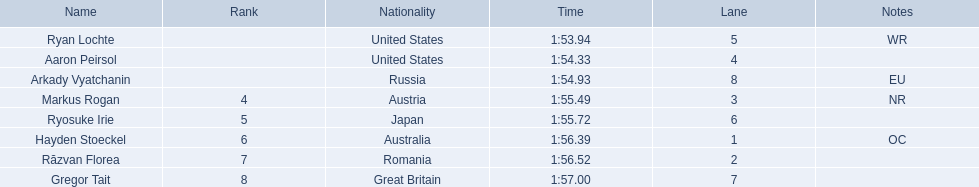Who are the swimmers? Ryan Lochte, Aaron Peirsol, Arkady Vyatchanin, Markus Rogan, Ryosuke Irie, Hayden Stoeckel, Răzvan Florea, Gregor Tait. What is ryosuke irie's time? 1:55.72. 